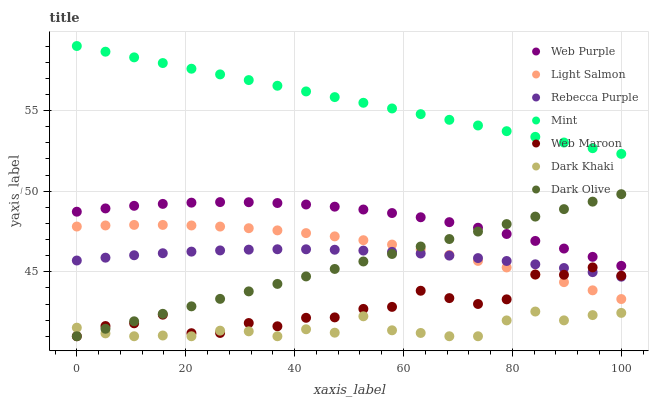Does Dark Khaki have the minimum area under the curve?
Answer yes or no. Yes. Does Mint have the maximum area under the curve?
Answer yes or no. Yes. Does Dark Olive have the minimum area under the curve?
Answer yes or no. No. Does Dark Olive have the maximum area under the curve?
Answer yes or no. No. Is Dark Olive the smoothest?
Answer yes or no. Yes. Is Web Maroon the roughest?
Answer yes or no. Yes. Is Web Maroon the smoothest?
Answer yes or no. No. Is Dark Olive the roughest?
Answer yes or no. No. Does Dark Olive have the lowest value?
Answer yes or no. Yes. Does Web Purple have the lowest value?
Answer yes or no. No. Does Mint have the highest value?
Answer yes or no. Yes. Does Dark Olive have the highest value?
Answer yes or no. No. Is Web Purple less than Mint?
Answer yes or no. Yes. Is Web Purple greater than Light Salmon?
Answer yes or no. Yes. Does Web Maroon intersect Dark Olive?
Answer yes or no. Yes. Is Web Maroon less than Dark Olive?
Answer yes or no. No. Is Web Maroon greater than Dark Olive?
Answer yes or no. No. Does Web Purple intersect Mint?
Answer yes or no. No. 